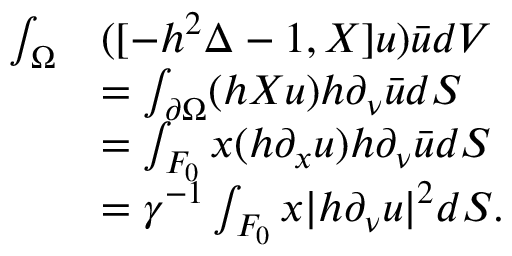Convert formula to latex. <formula><loc_0><loc_0><loc_500><loc_500>\begin{array} { r l } { \int _ { \Omega } } & { ( [ - h ^ { 2 } \Delta - 1 , X ] u ) \bar { u } d V } \\ & { = \int _ { \partial \Omega } ( h X u ) h \partial _ { \nu } \bar { u } d S } \\ & { = \int _ { F _ { 0 } } x ( h \partial _ { x } u ) h \partial _ { \nu } \bar { u } d S } \\ & { = \gamma ^ { - 1 } \int _ { F _ { 0 } } x | h \partial _ { \nu } u | ^ { 2 } d S . } \end{array}</formula> 